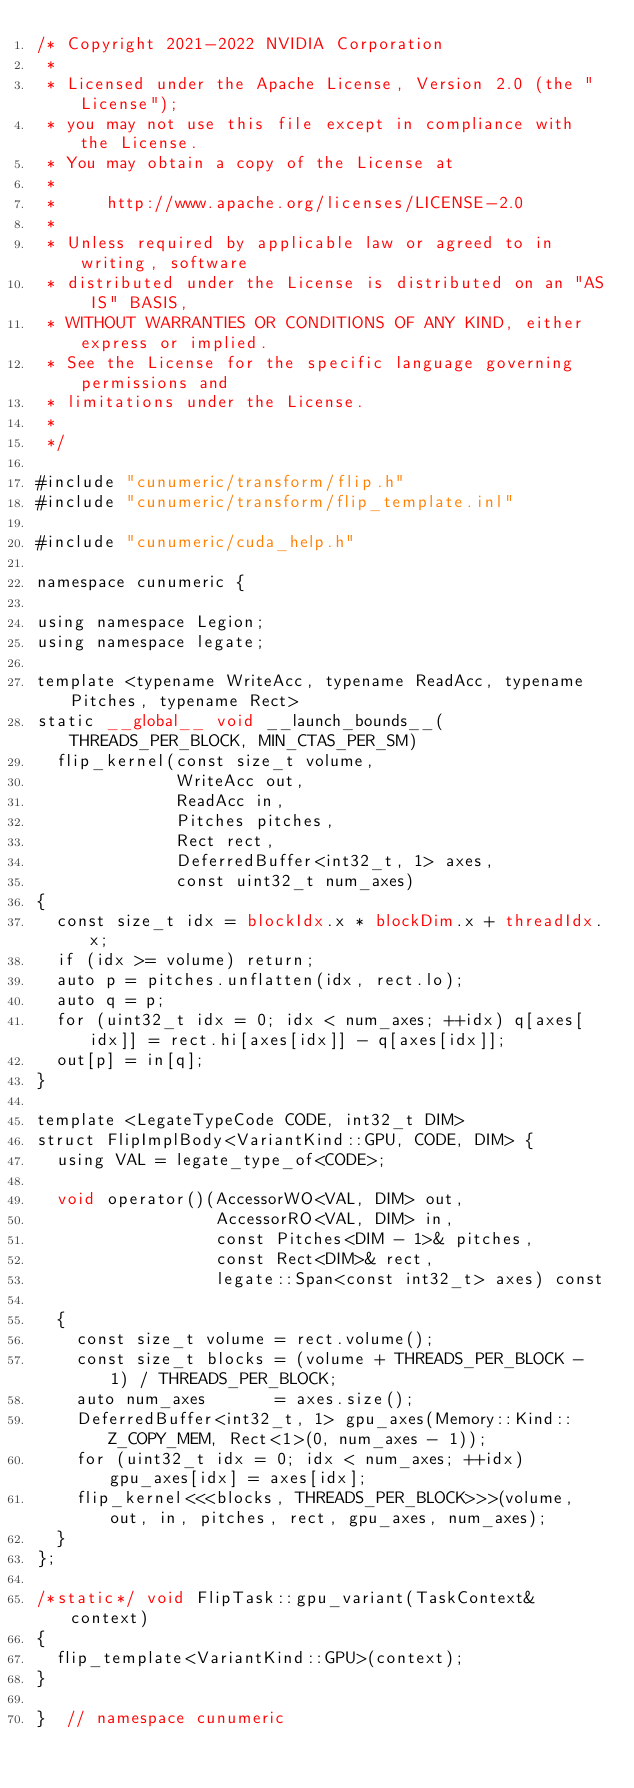<code> <loc_0><loc_0><loc_500><loc_500><_Cuda_>/* Copyright 2021-2022 NVIDIA Corporation
 *
 * Licensed under the Apache License, Version 2.0 (the "License");
 * you may not use this file except in compliance with the License.
 * You may obtain a copy of the License at
 *
 *     http://www.apache.org/licenses/LICENSE-2.0
 *
 * Unless required by applicable law or agreed to in writing, software
 * distributed under the License is distributed on an "AS IS" BASIS,
 * WITHOUT WARRANTIES OR CONDITIONS OF ANY KIND, either express or implied.
 * See the License for the specific language governing permissions and
 * limitations under the License.
 *
 */

#include "cunumeric/transform/flip.h"
#include "cunumeric/transform/flip_template.inl"

#include "cunumeric/cuda_help.h"

namespace cunumeric {

using namespace Legion;
using namespace legate;

template <typename WriteAcc, typename ReadAcc, typename Pitches, typename Rect>
static __global__ void __launch_bounds__(THREADS_PER_BLOCK, MIN_CTAS_PER_SM)
  flip_kernel(const size_t volume,
              WriteAcc out,
              ReadAcc in,
              Pitches pitches,
              Rect rect,
              DeferredBuffer<int32_t, 1> axes,
              const uint32_t num_axes)
{
  const size_t idx = blockIdx.x * blockDim.x + threadIdx.x;
  if (idx >= volume) return;
  auto p = pitches.unflatten(idx, rect.lo);
  auto q = p;
  for (uint32_t idx = 0; idx < num_axes; ++idx) q[axes[idx]] = rect.hi[axes[idx]] - q[axes[idx]];
  out[p] = in[q];
}

template <LegateTypeCode CODE, int32_t DIM>
struct FlipImplBody<VariantKind::GPU, CODE, DIM> {
  using VAL = legate_type_of<CODE>;

  void operator()(AccessorWO<VAL, DIM> out,
                  AccessorRO<VAL, DIM> in,
                  const Pitches<DIM - 1>& pitches,
                  const Rect<DIM>& rect,
                  legate::Span<const int32_t> axes) const

  {
    const size_t volume = rect.volume();
    const size_t blocks = (volume + THREADS_PER_BLOCK - 1) / THREADS_PER_BLOCK;
    auto num_axes       = axes.size();
    DeferredBuffer<int32_t, 1> gpu_axes(Memory::Kind::Z_COPY_MEM, Rect<1>(0, num_axes - 1));
    for (uint32_t idx = 0; idx < num_axes; ++idx) gpu_axes[idx] = axes[idx];
    flip_kernel<<<blocks, THREADS_PER_BLOCK>>>(volume, out, in, pitches, rect, gpu_axes, num_axes);
  }
};

/*static*/ void FlipTask::gpu_variant(TaskContext& context)
{
  flip_template<VariantKind::GPU>(context);
}

}  // namespace cunumeric
</code> 